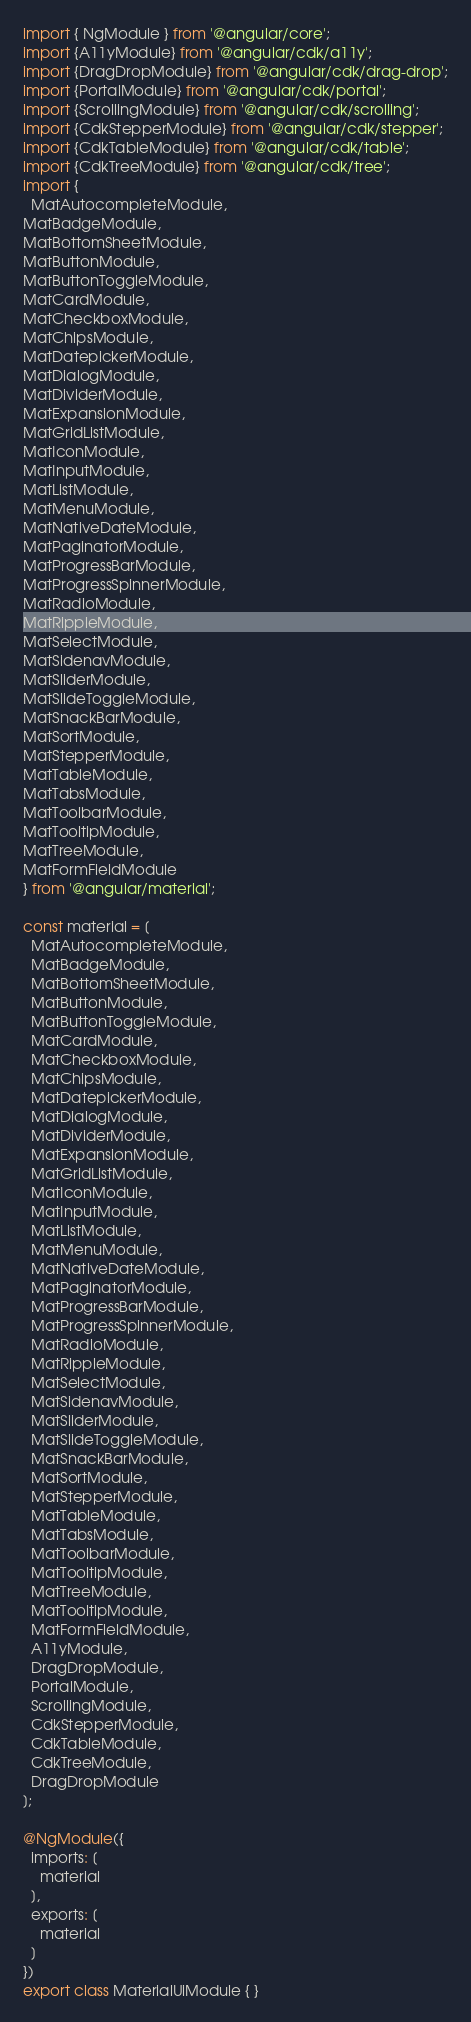Convert code to text. <code><loc_0><loc_0><loc_500><loc_500><_TypeScript_>import { NgModule } from '@angular/core';
import {A11yModule} from '@angular/cdk/a11y';
import {DragDropModule} from '@angular/cdk/drag-drop';
import {PortalModule} from '@angular/cdk/portal';
import {ScrollingModule} from '@angular/cdk/scrolling';
import {CdkStepperModule} from '@angular/cdk/stepper';
import {CdkTableModule} from '@angular/cdk/table';
import {CdkTreeModule} from '@angular/cdk/tree';
import {
  MatAutocompleteModule,
MatBadgeModule,
MatBottomSheetModule,
MatButtonModule,
MatButtonToggleModule,
MatCardModule,
MatCheckboxModule,
MatChipsModule,
MatDatepickerModule,
MatDialogModule,
MatDividerModule,
MatExpansionModule,
MatGridListModule,
MatIconModule,
MatInputModule,
MatListModule,
MatMenuModule,
MatNativeDateModule,
MatPaginatorModule,
MatProgressBarModule,
MatProgressSpinnerModule,
MatRadioModule,
MatRippleModule,
MatSelectModule,
MatSidenavModule,
MatSliderModule,
MatSlideToggleModule,
MatSnackBarModule,
MatSortModule,
MatStepperModule,
MatTableModule,
MatTabsModule,
MatToolbarModule,
MatTooltipModule,
MatTreeModule,
MatFormFieldModule
} from '@angular/material';

const material = [
  MatAutocompleteModule,
  MatBadgeModule,
  MatBottomSheetModule,
  MatButtonModule,
  MatButtonToggleModule,
  MatCardModule,
  MatCheckboxModule,
  MatChipsModule,
  MatDatepickerModule,
  MatDialogModule,
  MatDividerModule,
  MatExpansionModule,
  MatGridListModule,
  MatIconModule,
  MatInputModule,
  MatListModule,
  MatMenuModule,
  MatNativeDateModule,
  MatPaginatorModule,
  MatProgressBarModule,
  MatProgressSpinnerModule,
  MatRadioModule,
  MatRippleModule,
  MatSelectModule,
  MatSidenavModule,
  MatSliderModule,
  MatSlideToggleModule,
  MatSnackBarModule,
  MatSortModule,
  MatStepperModule,
  MatTableModule,
  MatTabsModule,
  MatToolbarModule,
  MatTooltipModule,
  MatTreeModule,
  MatTooltipModule,
  MatFormFieldModule,
  A11yModule,
  DragDropModule,
  PortalModule,
  ScrollingModule,
  CdkStepperModule,
  CdkTableModule,
  CdkTreeModule,
  DragDropModule
];

@NgModule({
  imports: [
    material
  ],
  exports: [
    material
  ]
})
export class MaterialUiModule { }
</code> 